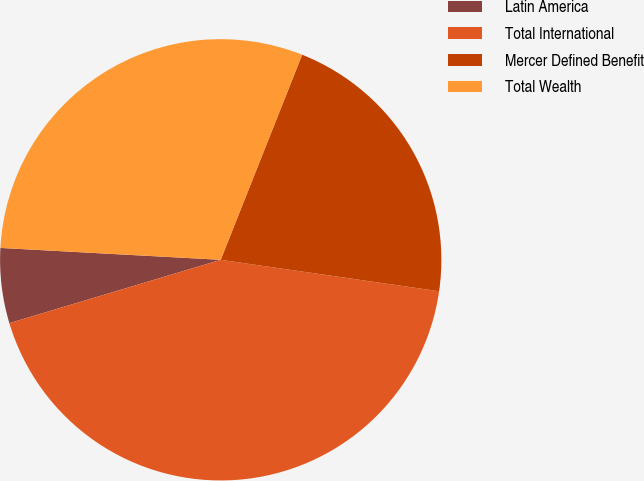<chart> <loc_0><loc_0><loc_500><loc_500><pie_chart><fcel>Latin America<fcel>Total International<fcel>Mercer Defined Benefit<fcel>Total Wealth<nl><fcel>5.49%<fcel>43.09%<fcel>21.26%<fcel>30.16%<nl></chart> 